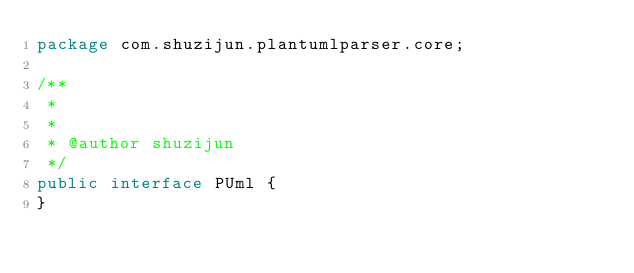<code> <loc_0><loc_0><loc_500><loc_500><_Java_>package com.shuzijun.plantumlparser.core;

/**
 *
 *
 * @author shuzijun
 */
public interface PUml {
}
</code> 